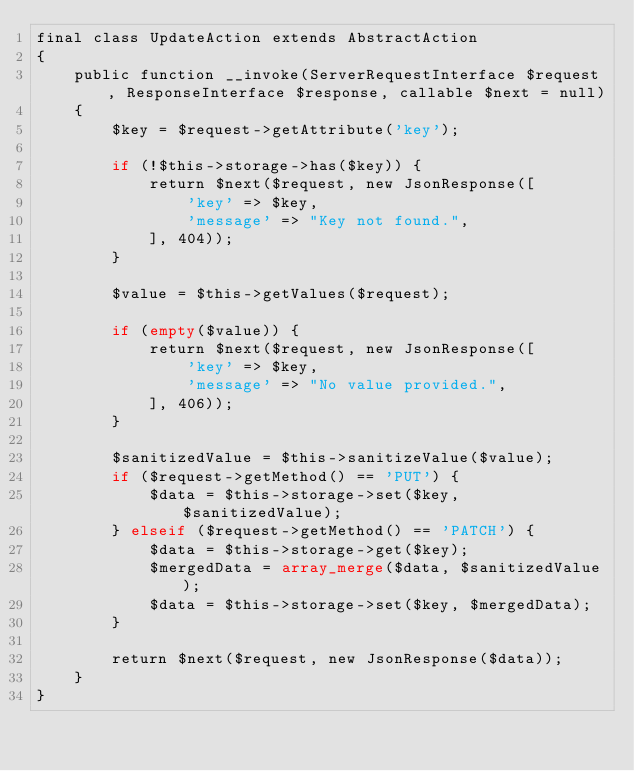<code> <loc_0><loc_0><loc_500><loc_500><_PHP_>final class UpdateAction extends AbstractAction
{
    public function __invoke(ServerRequestInterface $request, ResponseInterface $response, callable $next = null)
    {
        $key = $request->getAttribute('key');

        if (!$this->storage->has($key)) {
            return $next($request, new JsonResponse([
                'key' => $key,
                'message' => "Key not found.",
            ], 404));
        }

        $value = $this->getValues($request);

        if (empty($value)) {
            return $next($request, new JsonResponse([
                'key' => $key,
                'message' => "No value provided.",
            ], 406));
        }

        $sanitizedValue = $this->sanitizeValue($value);
        if ($request->getMethod() == 'PUT') {
            $data = $this->storage->set($key, $sanitizedValue);
        } elseif ($request->getMethod() == 'PATCH') {
            $data = $this->storage->get($key);
            $mergedData = array_merge($data, $sanitizedValue);
            $data = $this->storage->set($key, $mergedData);
        }

        return $next($request, new JsonResponse($data));
    }
}
</code> 